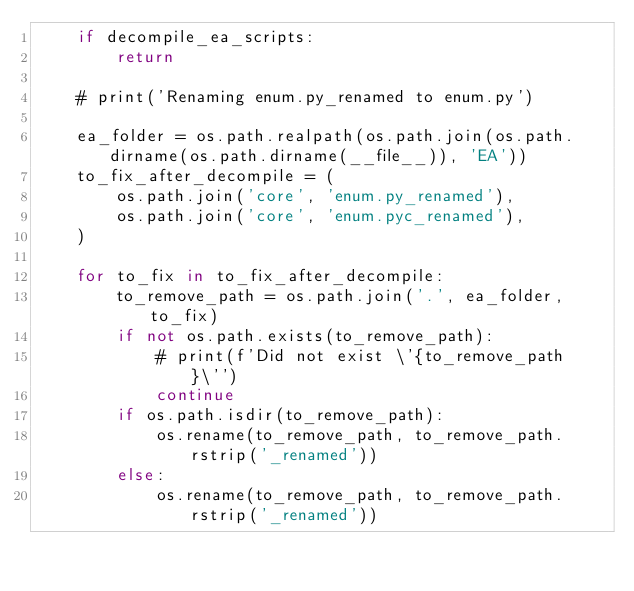Convert code to text. <code><loc_0><loc_0><loc_500><loc_500><_Python_>    if decompile_ea_scripts:
        return

    # print('Renaming enum.py_renamed to enum.py')

    ea_folder = os.path.realpath(os.path.join(os.path.dirname(os.path.dirname(__file__)), 'EA'))
    to_fix_after_decompile = (
        os.path.join('core', 'enum.py_renamed'),
        os.path.join('core', 'enum.pyc_renamed'),
    )

    for to_fix in to_fix_after_decompile:
        to_remove_path = os.path.join('.', ea_folder, to_fix)
        if not os.path.exists(to_remove_path):
            # print(f'Did not exist \'{to_remove_path}\'')
            continue
        if os.path.isdir(to_remove_path):
            os.rename(to_remove_path, to_remove_path.rstrip('_renamed'))
        else:
            os.rename(to_remove_path, to_remove_path.rstrip('_renamed'))</code> 